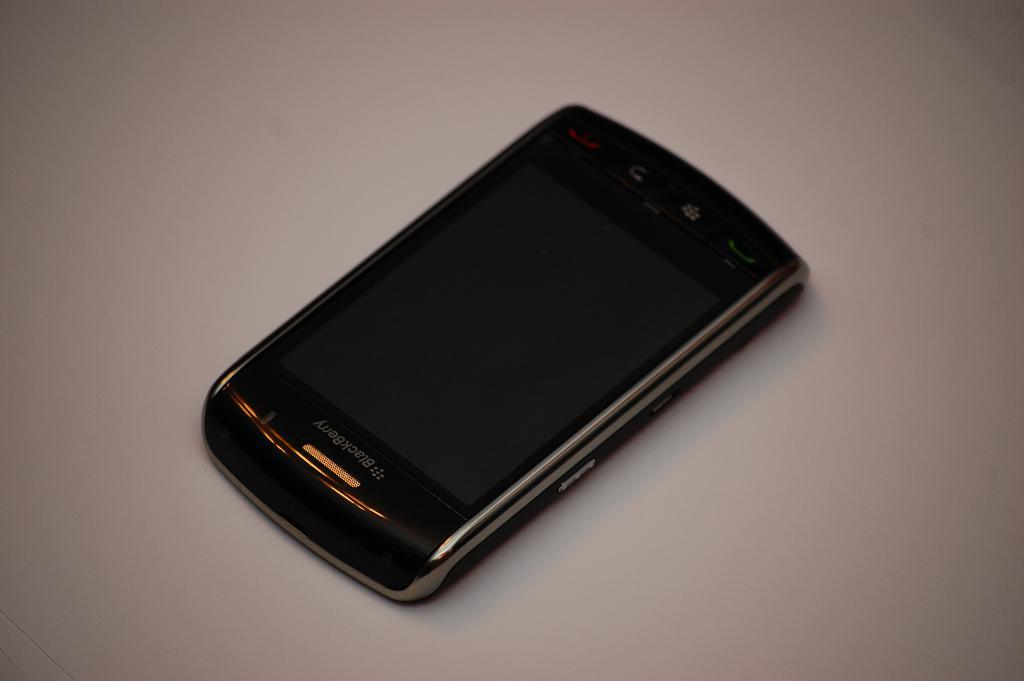<image>
Write a terse but informative summary of the picture. A touchscreen blackberry phone lies on a gray surface. 